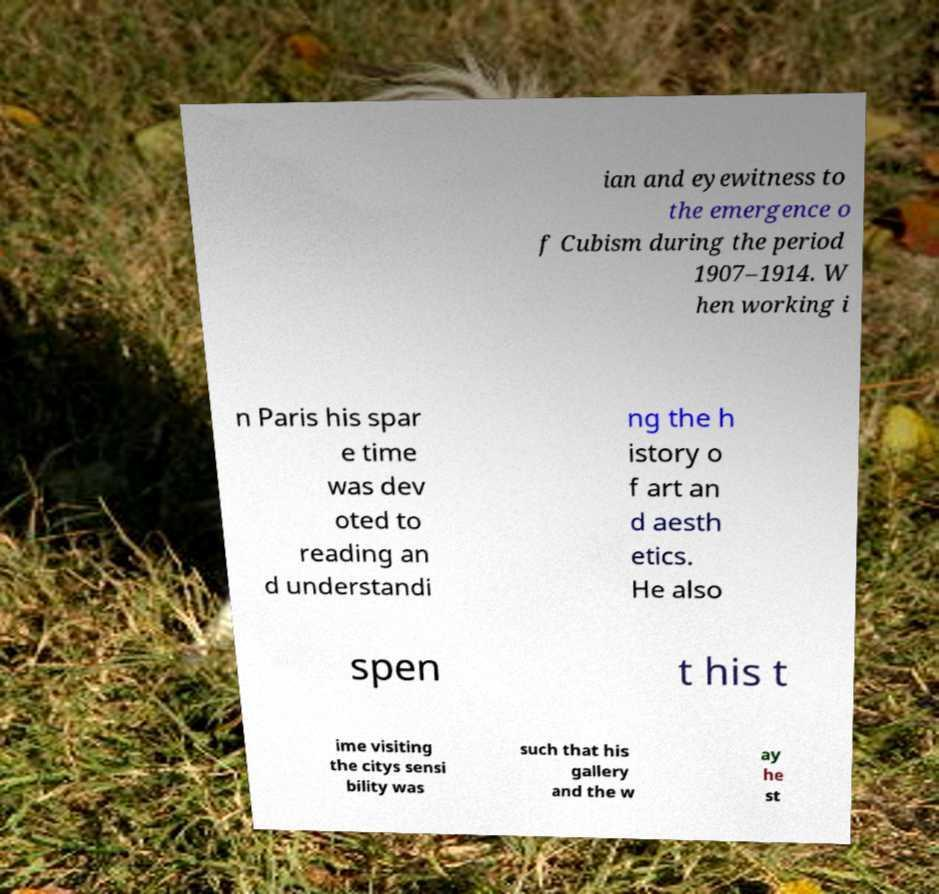Could you extract and type out the text from this image? ian and eyewitness to the emergence o f Cubism during the period 1907–1914. W hen working i n Paris his spar e time was dev oted to reading an d understandi ng the h istory o f art an d aesth etics. He also spen t his t ime visiting the citys sensi bility was such that his gallery and the w ay he st 